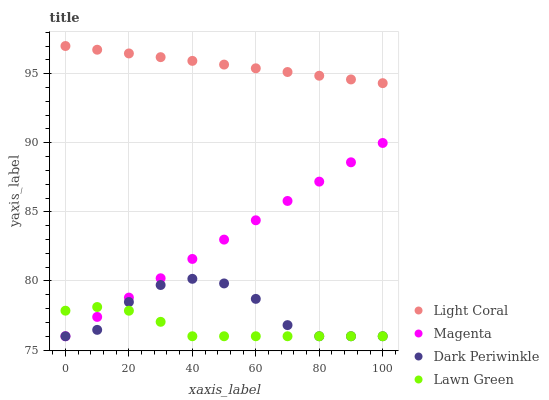Does Lawn Green have the minimum area under the curve?
Answer yes or no. Yes. Does Light Coral have the maximum area under the curve?
Answer yes or no. Yes. Does Magenta have the minimum area under the curve?
Answer yes or no. No. Does Magenta have the maximum area under the curve?
Answer yes or no. No. Is Light Coral the smoothest?
Answer yes or no. Yes. Is Dark Periwinkle the roughest?
Answer yes or no. Yes. Is Lawn Green the smoothest?
Answer yes or no. No. Is Lawn Green the roughest?
Answer yes or no. No. Does Lawn Green have the lowest value?
Answer yes or no. Yes. Does Light Coral have the highest value?
Answer yes or no. Yes. Does Magenta have the highest value?
Answer yes or no. No. Is Magenta less than Light Coral?
Answer yes or no. Yes. Is Light Coral greater than Magenta?
Answer yes or no. Yes. Does Lawn Green intersect Dark Periwinkle?
Answer yes or no. Yes. Is Lawn Green less than Dark Periwinkle?
Answer yes or no. No. Is Lawn Green greater than Dark Periwinkle?
Answer yes or no. No. Does Magenta intersect Light Coral?
Answer yes or no. No. 